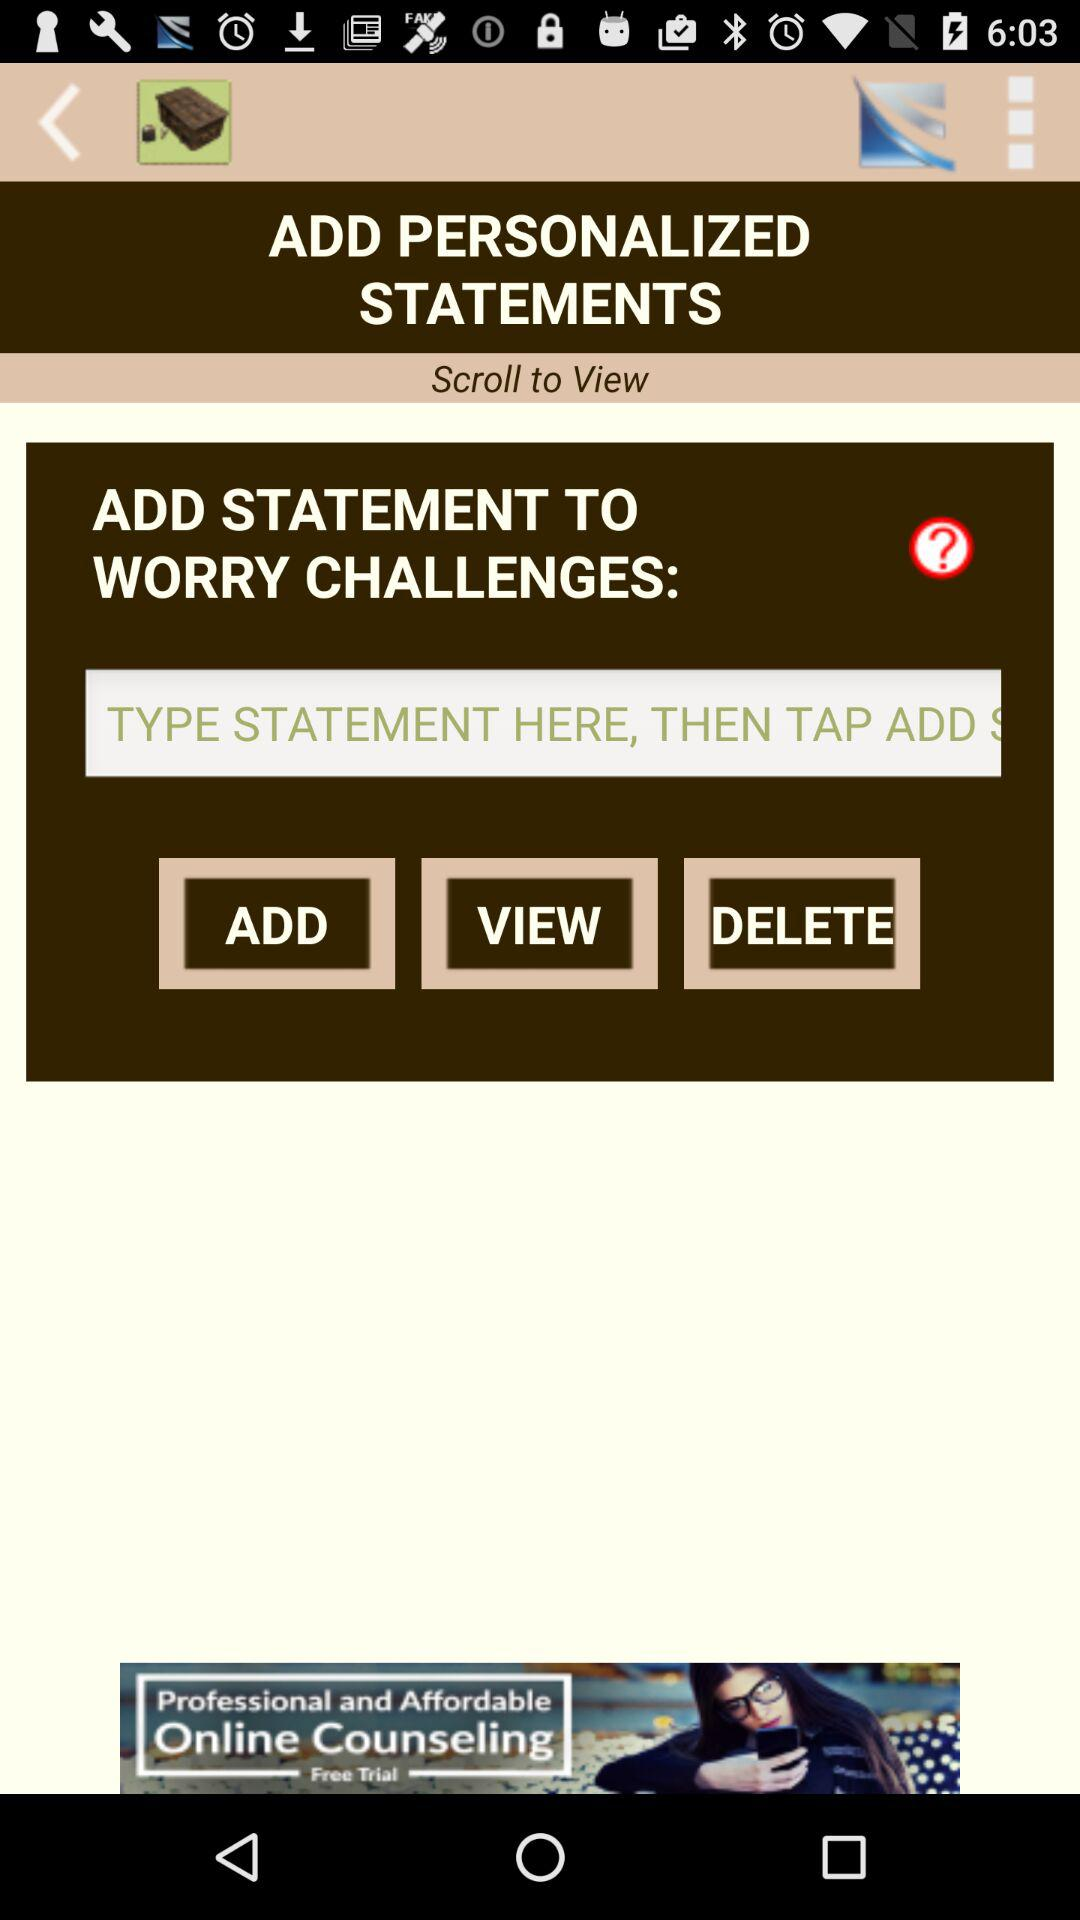What do I have to do to view? You have to scroll to view. 